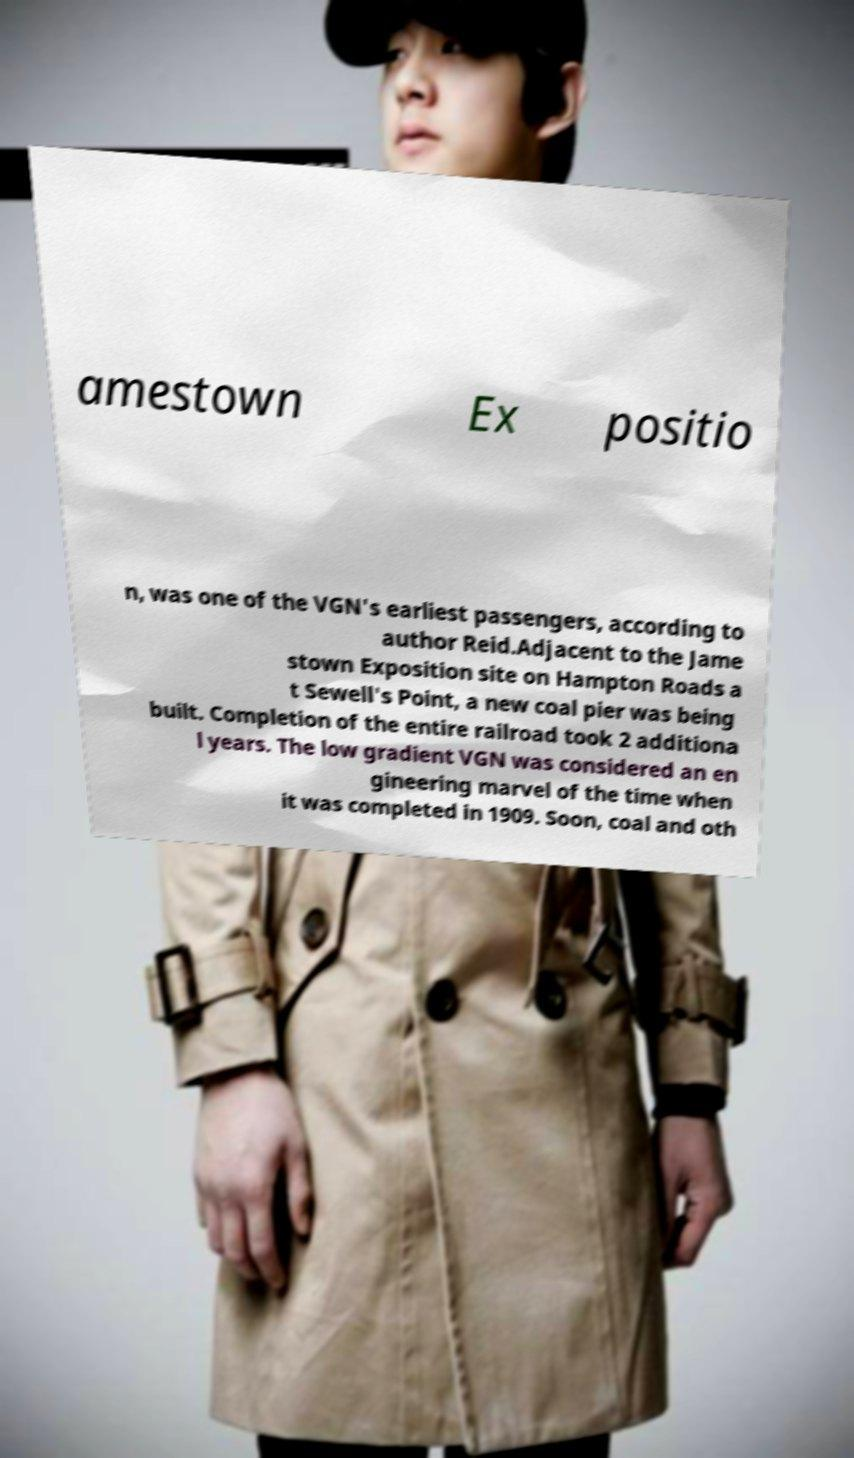Please identify and transcribe the text found in this image. amestown Ex positio n, was one of the VGN's earliest passengers, according to author Reid.Adjacent to the Jame stown Exposition site on Hampton Roads a t Sewell's Point, a new coal pier was being built. Completion of the entire railroad took 2 additiona l years. The low gradient VGN was considered an en gineering marvel of the time when it was completed in 1909. Soon, coal and oth 